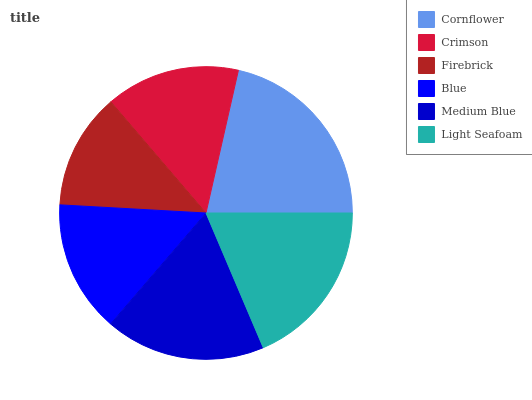Is Firebrick the minimum?
Answer yes or no. Yes. Is Cornflower the maximum?
Answer yes or no. Yes. Is Crimson the minimum?
Answer yes or no. No. Is Crimson the maximum?
Answer yes or no. No. Is Cornflower greater than Crimson?
Answer yes or no. Yes. Is Crimson less than Cornflower?
Answer yes or no. Yes. Is Crimson greater than Cornflower?
Answer yes or no. No. Is Cornflower less than Crimson?
Answer yes or no. No. Is Medium Blue the high median?
Answer yes or no. Yes. Is Crimson the low median?
Answer yes or no. Yes. Is Light Seafoam the high median?
Answer yes or no. No. Is Medium Blue the low median?
Answer yes or no. No. 